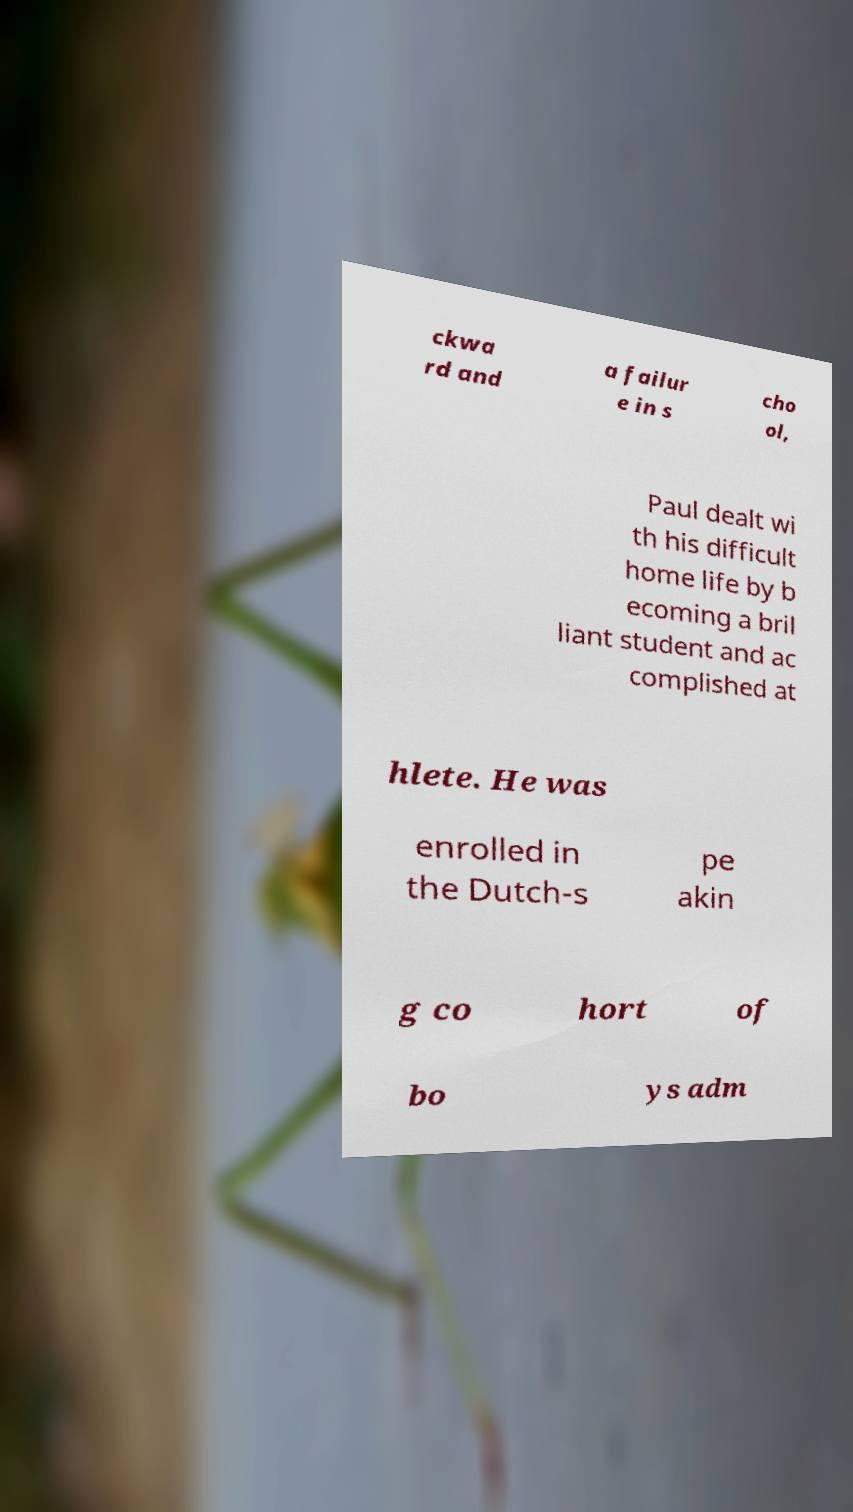Can you read and provide the text displayed in the image?This photo seems to have some interesting text. Can you extract and type it out for me? ckwa rd and a failur e in s cho ol, Paul dealt wi th his difficult home life by b ecoming a bril liant student and ac complished at hlete. He was enrolled in the Dutch-s pe akin g co hort of bo ys adm 